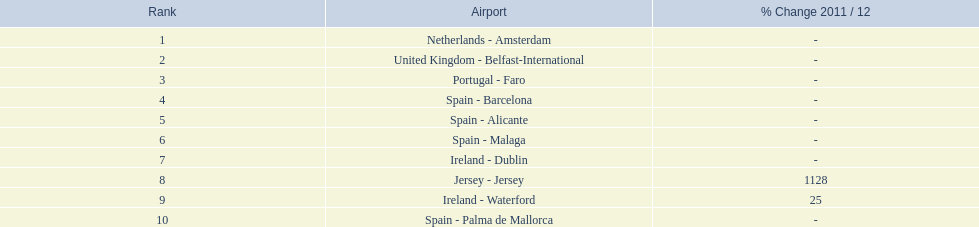What are the numbers of passengers handled along the different routes in the airport? 105,349, 92,502, 71,676, 66,565, 64,090, 59,175, 35,524, 35,169, 31,907, 27,718. Of these routes, which handles less than 30,000 passengers? Spain - Palma de Mallorca. 